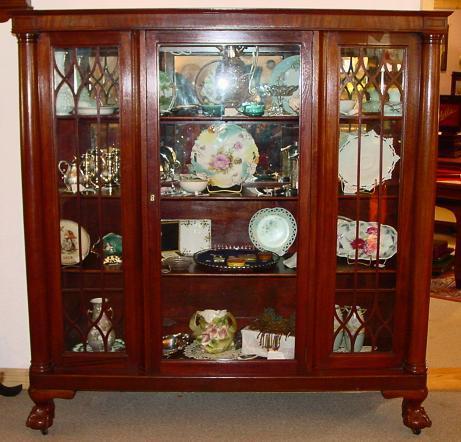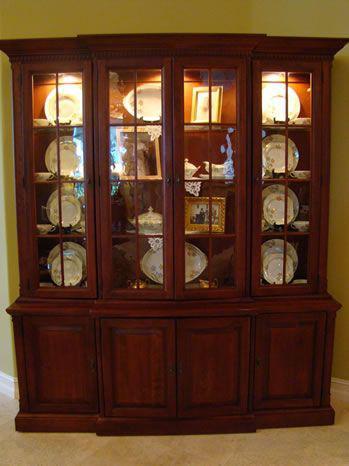The first image is the image on the left, the second image is the image on the right. Assess this claim about the two images: "A richly-colored brown cabinet has an arch shape at the center of the top and sits flush on the floor.". Correct or not? Answer yes or no. No. The first image is the image on the left, the second image is the image on the right. Considering the images on both sides, is "There is at least one chair in every image." valid? Answer yes or no. No. 